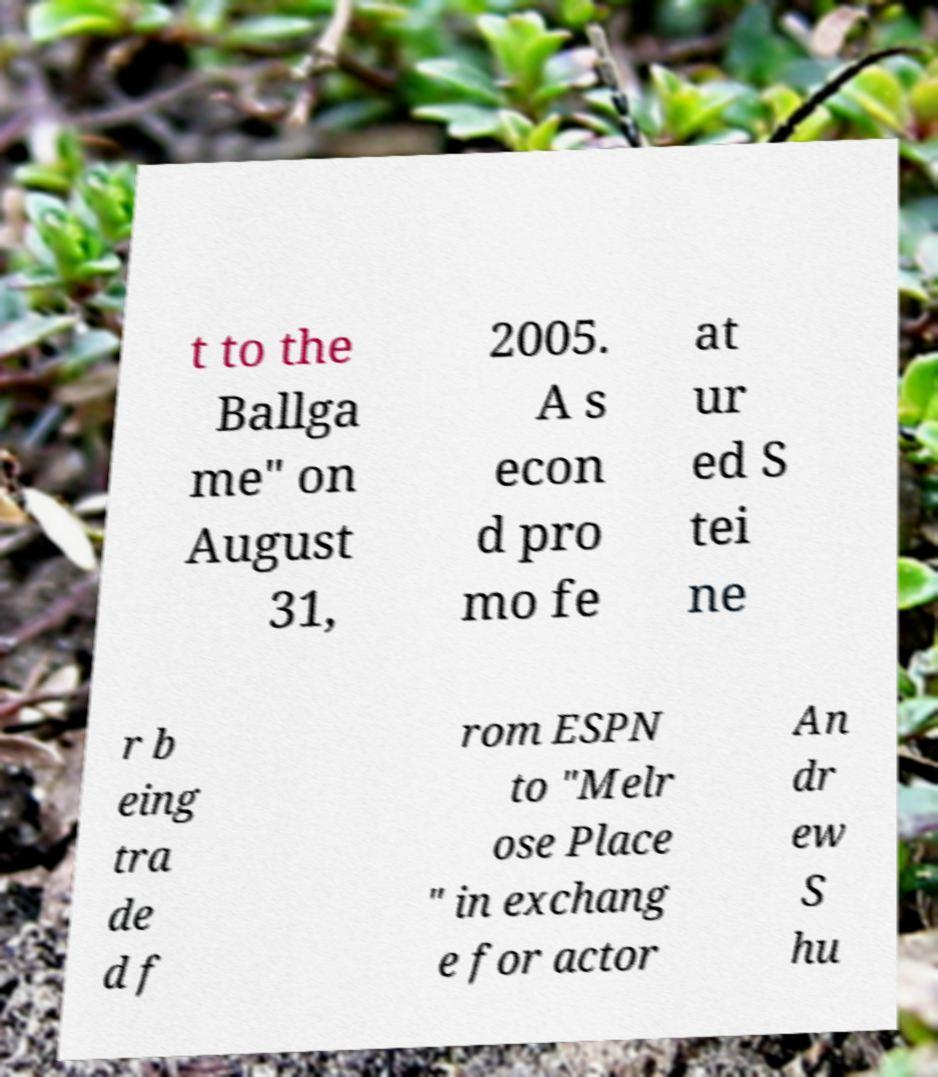Could you extract and type out the text from this image? t to the Ballga me" on August 31, 2005. A s econ d pro mo fe at ur ed S tei ne r b eing tra de d f rom ESPN to "Melr ose Place " in exchang e for actor An dr ew S hu 